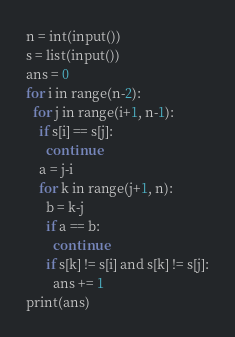<code> <loc_0><loc_0><loc_500><loc_500><_Python_>n = int(input())
s = list(input())
ans = 0
for i in range(n-2):
  for j in range(i+1, n-1):
    if s[i] == s[j]:
      continue
    a = j-i
    for k in range(j+1, n):
      b = k-j
      if a == b:
        continue
      if s[k] != s[i] and s[k] != s[j]:
        ans += 1
print(ans)
</code> 